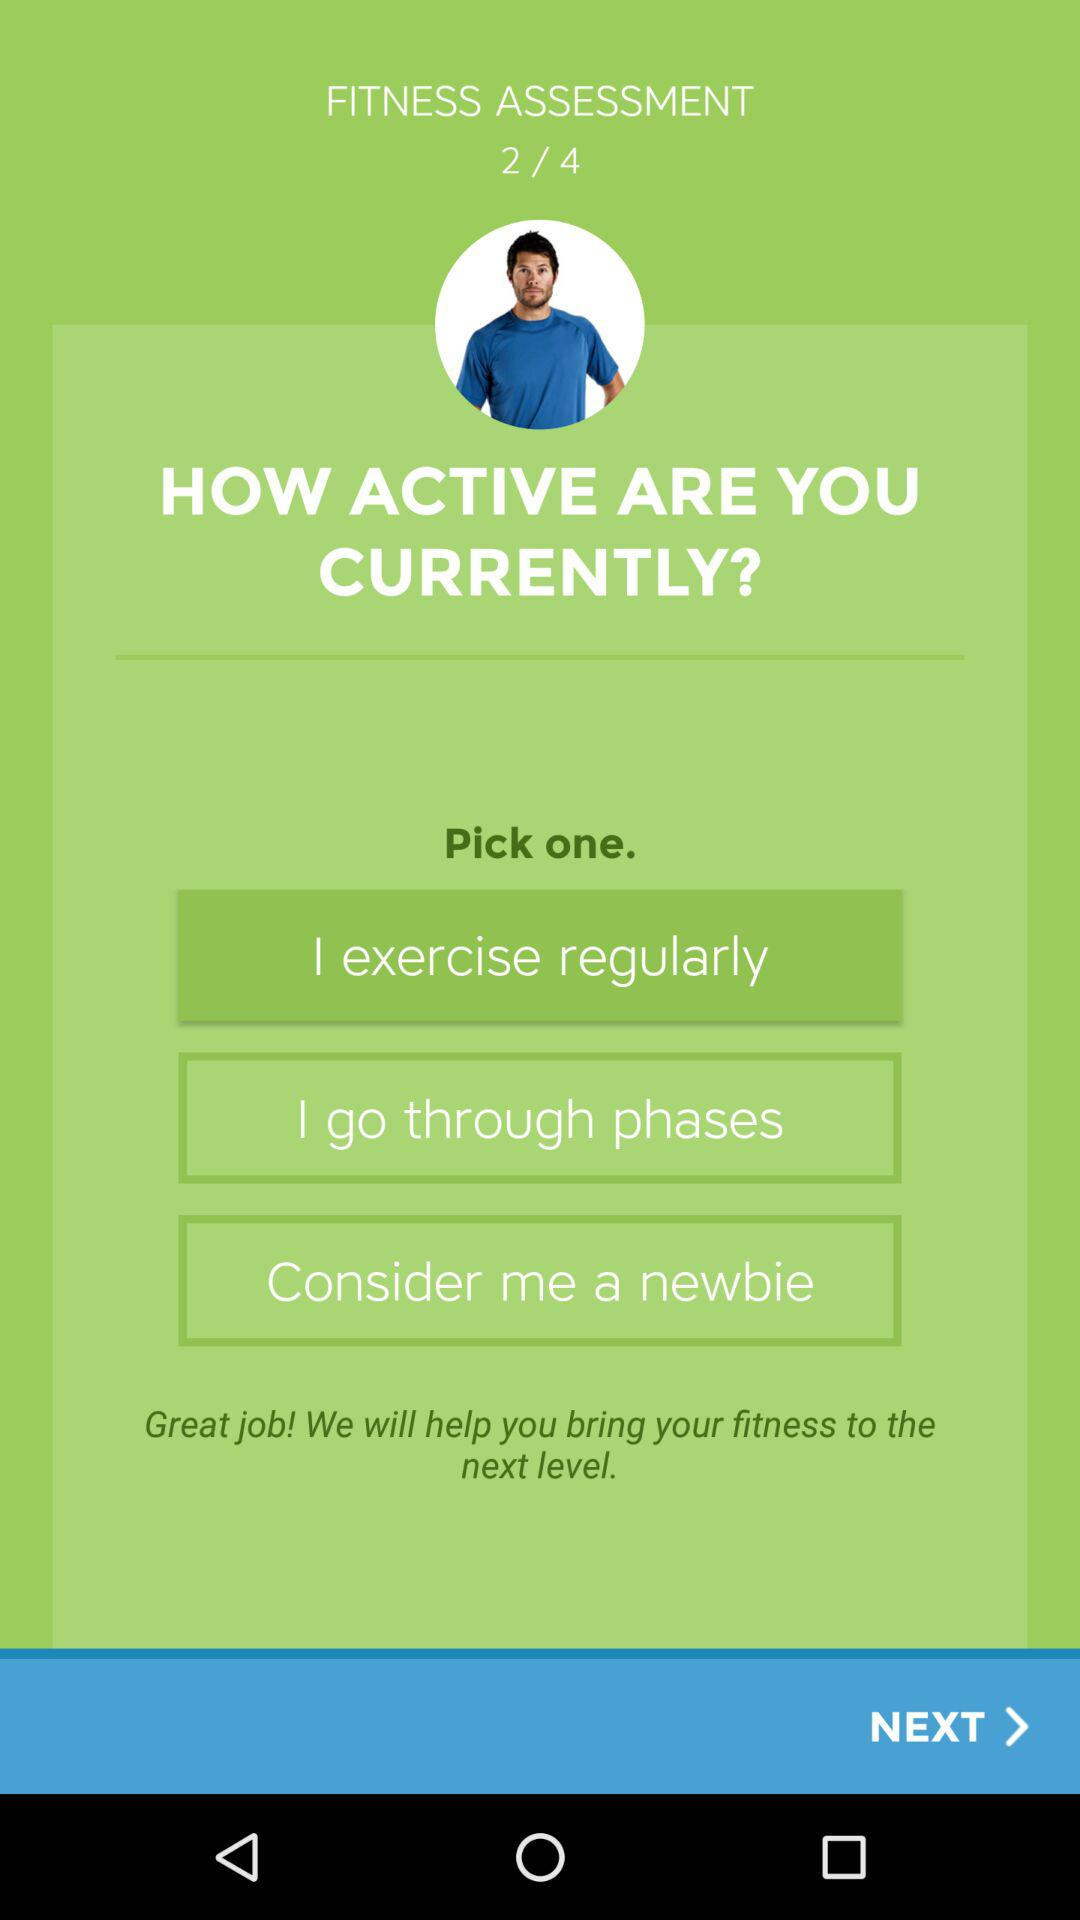What's the number of questions in "FITNESS ASSESSMENT"? The number of questions in "FITNESS ASSESSMENT" is 4. 